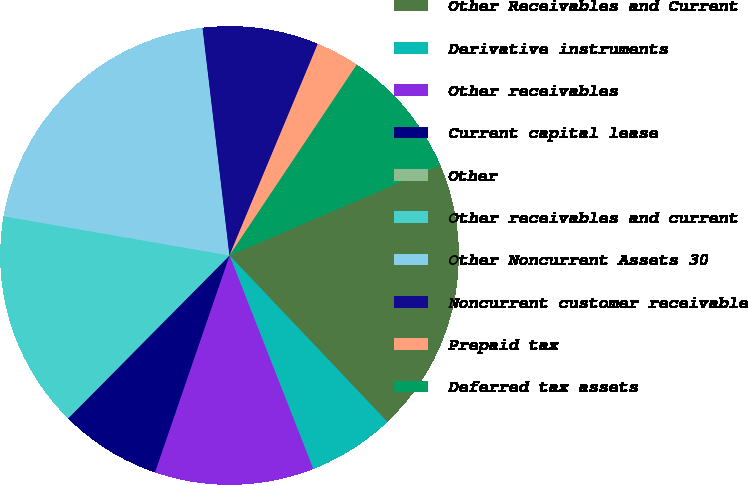Convert chart to OTSL. <chart><loc_0><loc_0><loc_500><loc_500><pie_chart><fcel>Other Receivables and Current<fcel>Derivative instruments<fcel>Other receivables<fcel>Current capital lease<fcel>Other<fcel>Other receivables and current<fcel>Other Noncurrent Assets 30<fcel>Noncurrent customer receivable<fcel>Prepaid tax<fcel>Deferred tax assets<nl><fcel>19.37%<fcel>6.13%<fcel>11.22%<fcel>7.15%<fcel>0.02%<fcel>15.3%<fcel>20.39%<fcel>8.17%<fcel>3.07%<fcel>9.19%<nl></chart> 